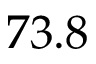<formula> <loc_0><loc_0><loc_500><loc_500>7 3 . 8</formula> 